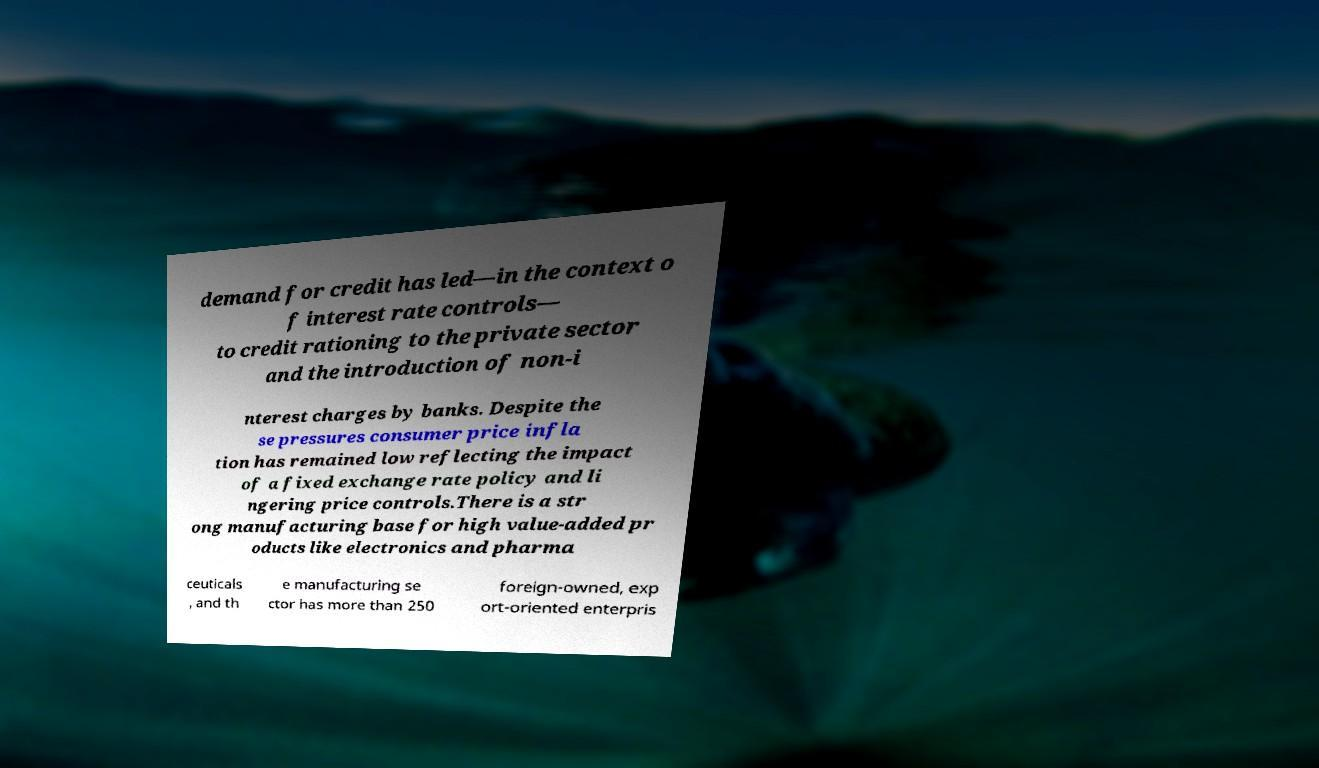Please identify and transcribe the text found in this image. demand for credit has led—in the context o f interest rate controls— to credit rationing to the private sector and the introduction of non-i nterest charges by banks. Despite the se pressures consumer price infla tion has remained low reflecting the impact of a fixed exchange rate policy and li ngering price controls.There is a str ong manufacturing base for high value-added pr oducts like electronics and pharma ceuticals , and th e manufacturing se ctor has more than 250 foreign-owned, exp ort-oriented enterpris 